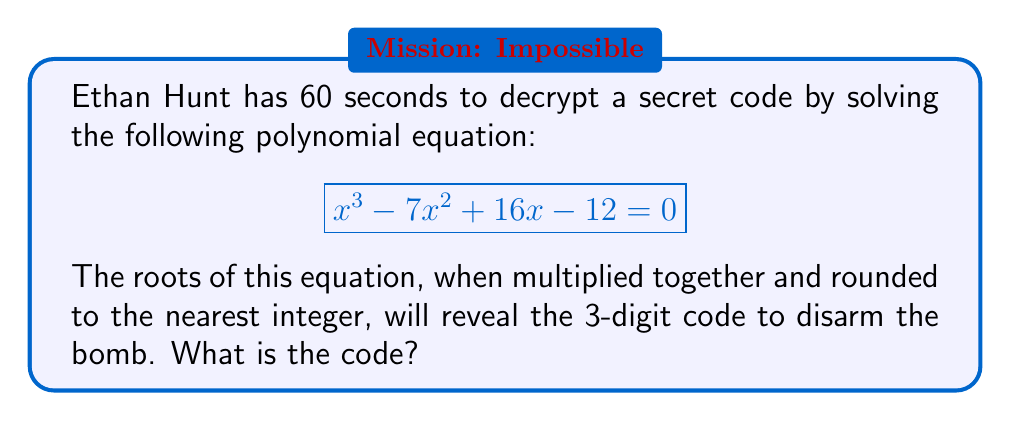Teach me how to tackle this problem. To solve this problem, we need to factor the polynomial and find its roots. Let's approach this step-by-step:

1) First, let's check if there are any rational roots using the rational root theorem. The possible rational roots are the factors of the constant term: ±1, ±2, ±3, ±4, ±6, ±12.

2) Testing these values, we find that x = 1 is a root. So (x - 1) is a factor.

3) We can now divide the original polynomial by (x - 1):

   $$ \frac{x^3 - 7x^2 + 16x - 12}{x - 1} = x^2 - 6x + 12 $$

4) Now we have reduced our problem to solving:

   $$ (x - 1)(x^2 - 6x + 12) = 0 $$

5) We can solve $x^2 - 6x + 12 = 0$ using the quadratic formula:

   $$ x = \frac{-b \pm \sqrt{b^2 - 4ac}}{2a} $$

   Where $a = 1$, $b = -6$, and $c = 12$

6) Plugging in these values:

   $$ x = \frac{6 \pm \sqrt{36 - 48}}{2} = \frac{6 \pm \sqrt{-12}}{2} = 3 \pm i\sqrt{3} $$

7) So our roots are:
   $x_1 = 1$
   $x_2 = 3 + i\sqrt{3}$
   $x_3 = 3 - i\sqrt{3}$

8) Multiplying these roots:

   $$ 1 \cdot (3 + i\sqrt{3}) \cdot (3 - i\sqrt{3}) = 1 \cdot (9 + 3) = 12 $$

9) Rounding to the nearest integer: 12

Therefore, the 3-digit code is 012.
Answer: 012 